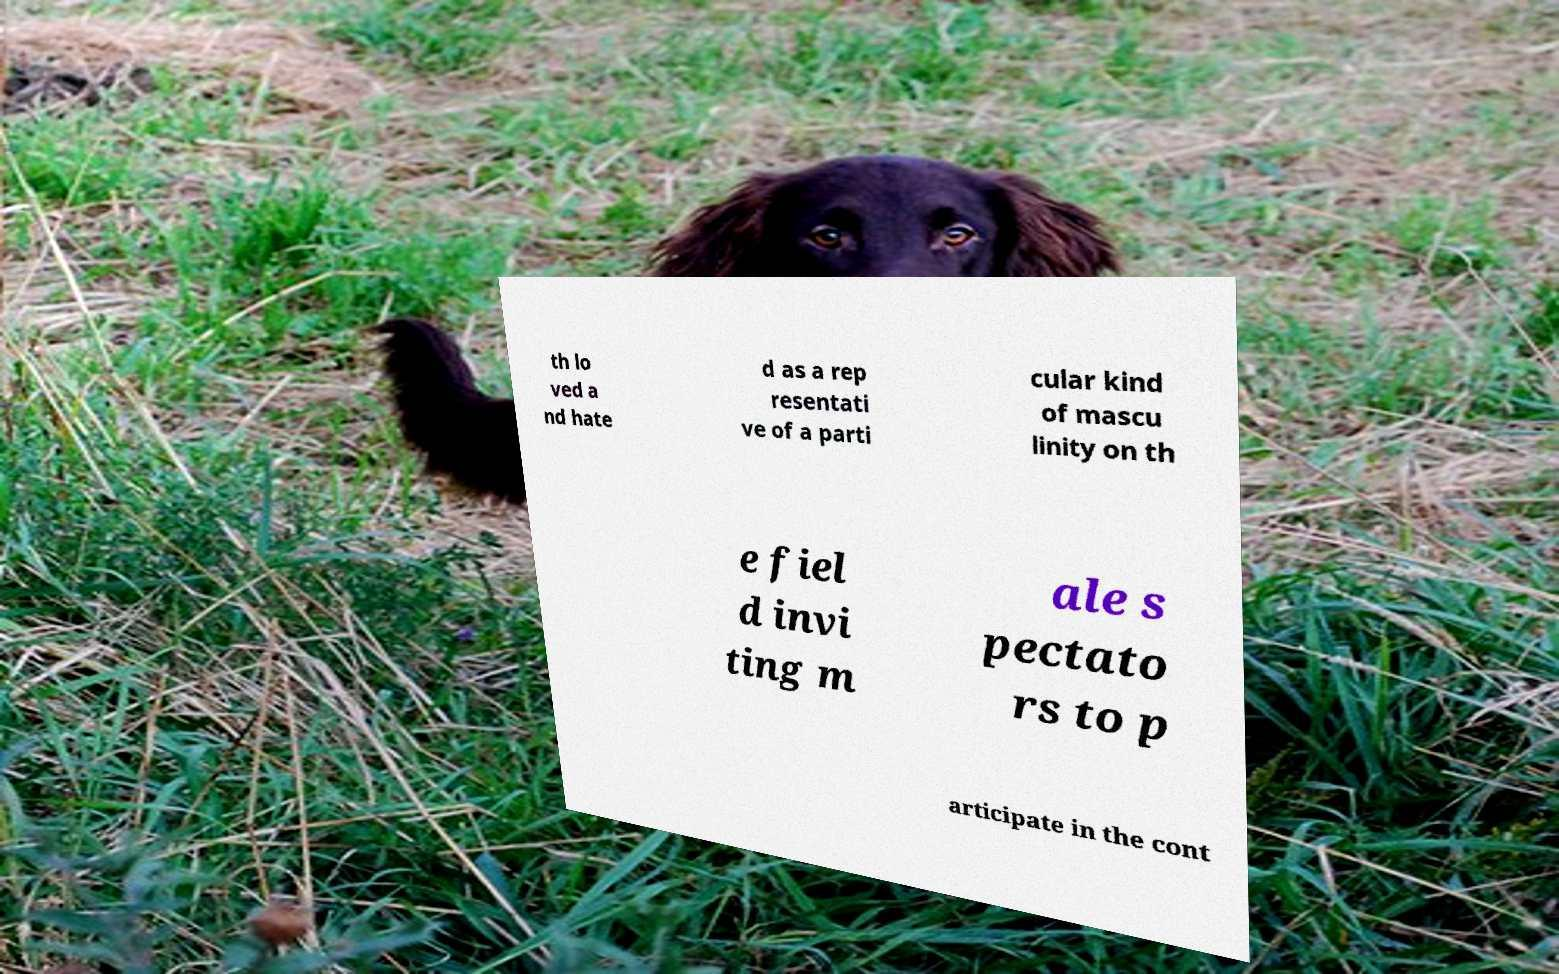Can you read and provide the text displayed in the image?This photo seems to have some interesting text. Can you extract and type it out for me? th lo ved a nd hate d as a rep resentati ve of a parti cular kind of mascu linity on th e fiel d invi ting m ale s pectato rs to p articipate in the cont 